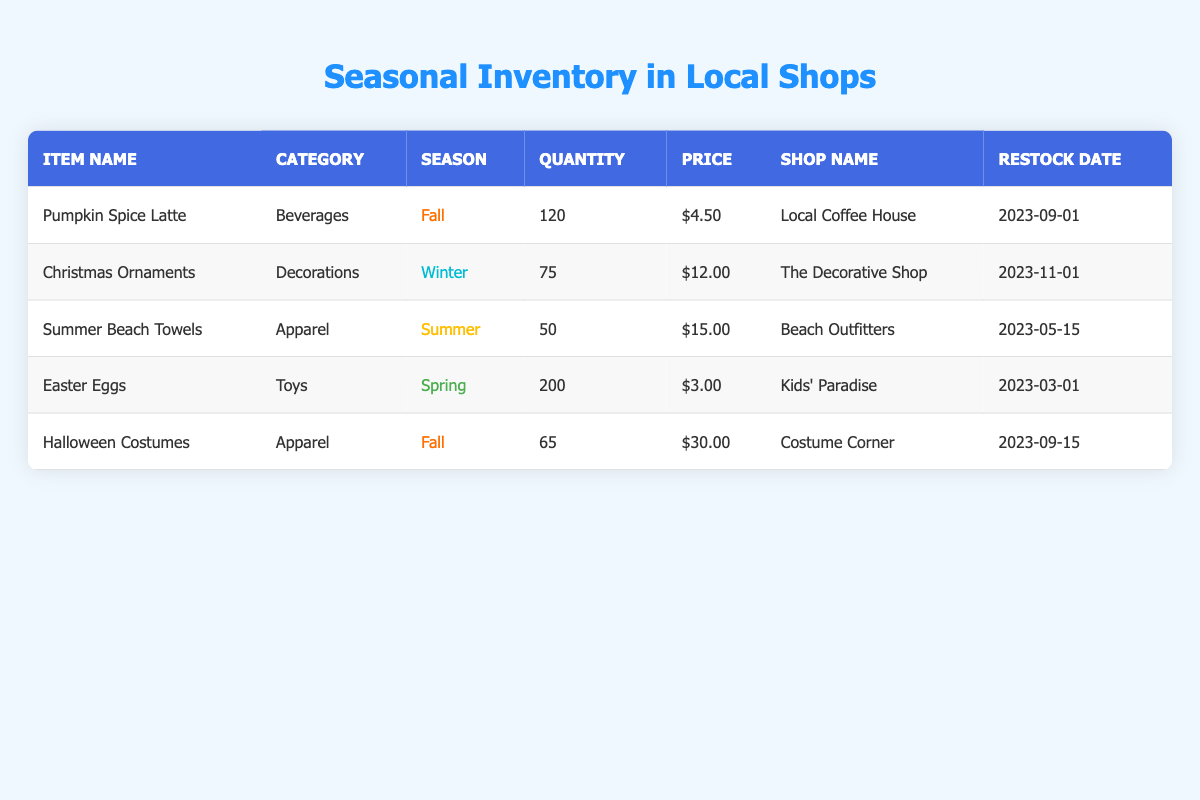What item has the highest quantity available? By scanning the inventory, we can see that "Easter Eggs" have the highest quantity at 200 units, compared to the other items.
Answer: Easter Eggs Which shop sells "Halloween Costumes"? "Halloween Costumes" are sold at "Costume Corner" as indicated in the shop name column for that item.
Answer: Costume Corner How many total "Fall" seasonal items are there? There are two items categorized under "Fall": "Pumpkin Spice Latte" with 120 units and "Halloween Costumes" with 65 units. Adding them gives 120 + 65 = 185 units.
Answer: 185 Is "Summer Beach Towels" priced lower than "Christmas Ornaments"? Comparing their prices, "Summer Beach Towels" are priced at $15.00 each, while "Christmas Ornaments" are priced at $12.00 each. Since $15.00 is greater than $12.00, the statement is false.
Answer: No What are the total quantities of items available across all seasons? We add the quantities of all items: 120 (Pumpkin Spice Latte) + 75 (Christmas Ornaments) + 50 (Summer Beach Towels) + 200 (Easter Eggs) + 65 (Halloween Costumes) = 510.
Answer: 510 Which item has the highest price per unit? Checking the price per unit, "Halloween Costumes" at $30.00 is higher than "Pumpkin Spice Latte" at $4.50, "Christmas Ornaments" at $12.00, "Summer Beach Towels" at $15.00, and "Easter Eggs" at $3.00. Thus, the item with the highest price is "Halloween Costumes."
Answer: Halloween Costumes How many more units of "Easter Eggs" are there than "Christmas Ornaments"? Subtracting the quantity of "Christmas Ornaments" (75) from "Easter Eggs" (200), we find 200 - 75 = 125 more units available.
Answer: 125 Does "The Decorative Shop" have any items in the fall season? Looking through the inventory, "The Decorative Shop" only sells "Christmas Ornaments" which are categorized as winter, indicating that there are no fall season items available at that shop.
Answer: No 